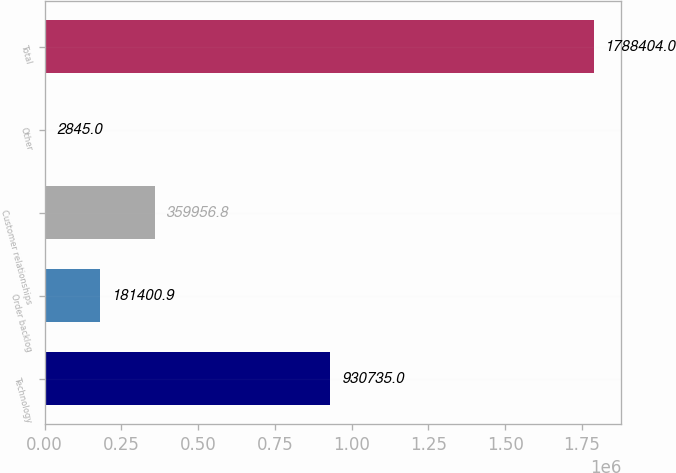Convert chart to OTSL. <chart><loc_0><loc_0><loc_500><loc_500><bar_chart><fcel>Technology<fcel>Order backlog<fcel>Customer relationships<fcel>Other<fcel>Total<nl><fcel>930735<fcel>181401<fcel>359957<fcel>2845<fcel>1.7884e+06<nl></chart> 